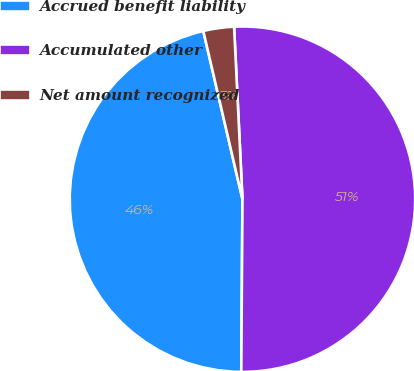<chart> <loc_0><loc_0><loc_500><loc_500><pie_chart><fcel>Accrued benefit liability<fcel>Accumulated other<fcel>Net amount recognized<nl><fcel>46.25%<fcel>50.88%<fcel>2.87%<nl></chart> 